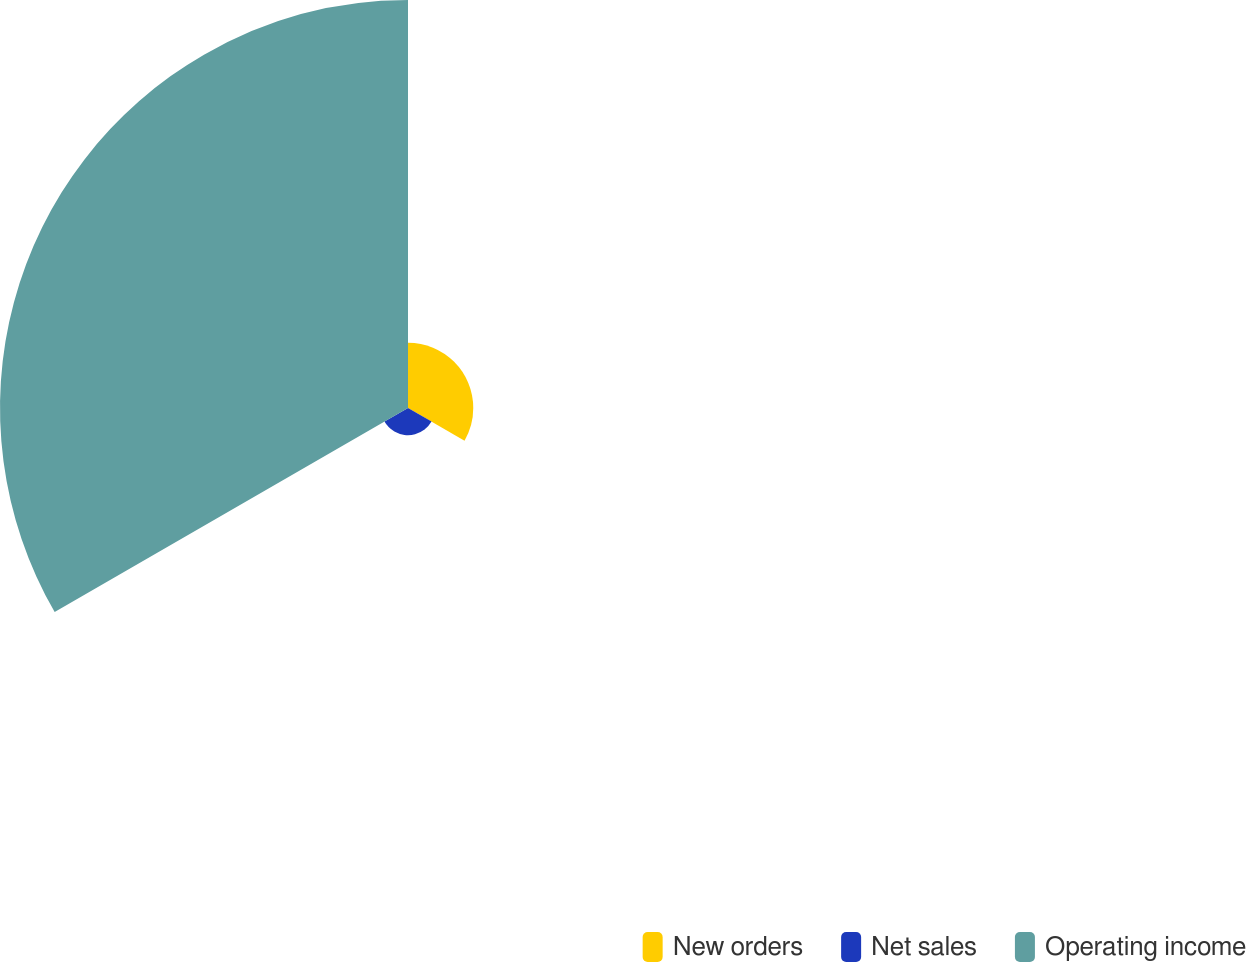<chart> <loc_0><loc_0><loc_500><loc_500><pie_chart><fcel>New orders<fcel>Net sales<fcel>Operating income<nl><fcel>13.04%<fcel>5.43%<fcel>81.52%<nl></chart> 